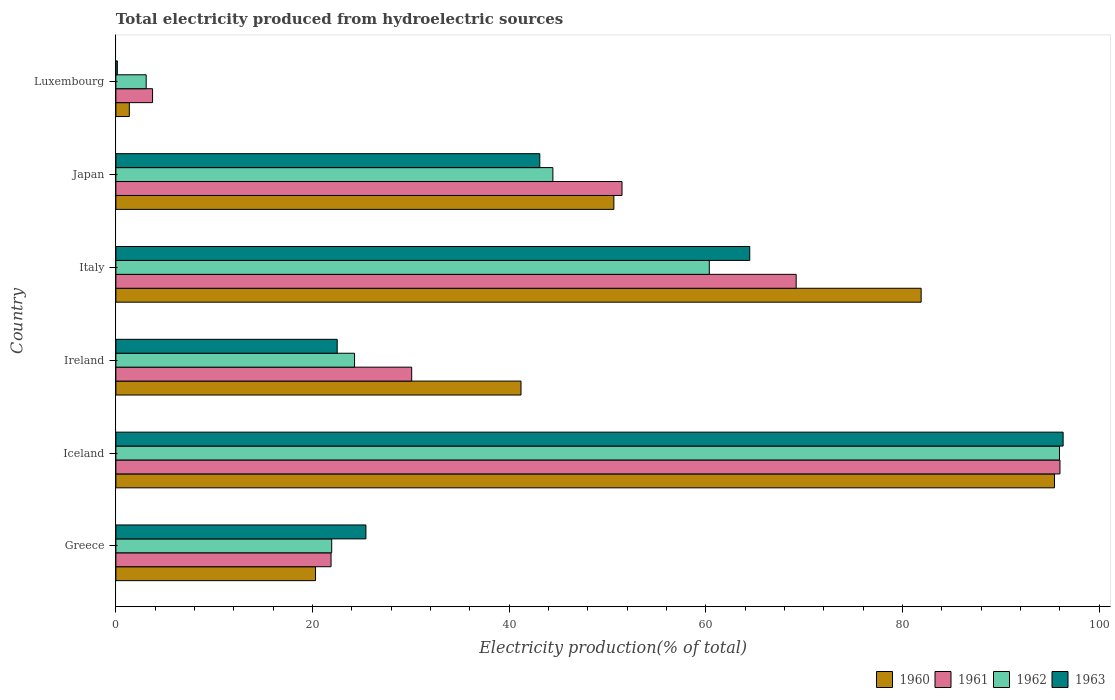Are the number of bars on each tick of the Y-axis equal?
Your response must be concise. Yes. How many bars are there on the 3rd tick from the top?
Your answer should be compact. 4. How many bars are there on the 1st tick from the bottom?
Offer a terse response. 4. What is the label of the 3rd group of bars from the top?
Make the answer very short. Italy. In how many cases, is the number of bars for a given country not equal to the number of legend labels?
Your answer should be compact. 0. What is the total electricity produced in 1962 in Luxembourg?
Your answer should be very brief. 3.08. Across all countries, what is the maximum total electricity produced in 1960?
Keep it short and to the point. 95.46. Across all countries, what is the minimum total electricity produced in 1962?
Offer a very short reply. 3.08. In which country was the total electricity produced in 1961 maximum?
Your answer should be very brief. Iceland. In which country was the total electricity produced in 1963 minimum?
Your response must be concise. Luxembourg. What is the total total electricity produced in 1960 in the graph?
Ensure brevity in your answer.  290.89. What is the difference between the total electricity produced in 1960 in Ireland and that in Italy?
Your answer should be very brief. -40.7. What is the difference between the total electricity produced in 1963 in Greece and the total electricity produced in 1961 in Iceland?
Your answer should be compact. -70.59. What is the average total electricity produced in 1962 per country?
Offer a terse response. 41.68. What is the difference between the total electricity produced in 1963 and total electricity produced in 1960 in Luxembourg?
Give a very brief answer. -1.22. What is the ratio of the total electricity produced in 1960 in Greece to that in Iceland?
Offer a very short reply. 0.21. What is the difference between the highest and the second highest total electricity produced in 1961?
Offer a very short reply. 26.83. What is the difference between the highest and the lowest total electricity produced in 1960?
Make the answer very short. 94.1. In how many countries, is the total electricity produced in 1962 greater than the average total electricity produced in 1962 taken over all countries?
Give a very brief answer. 3. What does the 3rd bar from the bottom in Japan represents?
Your answer should be very brief. 1962. How many bars are there?
Provide a short and direct response. 24. What is the difference between two consecutive major ticks on the X-axis?
Give a very brief answer. 20. Are the values on the major ticks of X-axis written in scientific E-notation?
Your answer should be very brief. No. Where does the legend appear in the graph?
Your answer should be very brief. Bottom right. How many legend labels are there?
Your response must be concise. 4. How are the legend labels stacked?
Provide a succinct answer. Horizontal. What is the title of the graph?
Ensure brevity in your answer.  Total electricity produced from hydroelectric sources. Does "1973" appear as one of the legend labels in the graph?
Your answer should be very brief. No. What is the label or title of the Y-axis?
Your response must be concise. Country. What is the Electricity production(% of total) in 1960 in Greece?
Your response must be concise. 20.31. What is the Electricity production(% of total) in 1961 in Greece?
Provide a short and direct response. 21.88. What is the Electricity production(% of total) in 1962 in Greece?
Ensure brevity in your answer.  21.95. What is the Electricity production(% of total) of 1963 in Greece?
Offer a very short reply. 25.43. What is the Electricity production(% of total) in 1960 in Iceland?
Offer a terse response. 95.46. What is the Electricity production(% of total) of 1961 in Iceland?
Offer a terse response. 96.02. What is the Electricity production(% of total) of 1962 in Iceland?
Make the answer very short. 95.97. What is the Electricity production(% of total) in 1963 in Iceland?
Give a very brief answer. 96.34. What is the Electricity production(% of total) in 1960 in Ireland?
Your answer should be compact. 41.2. What is the Electricity production(% of total) in 1961 in Ireland?
Your answer should be very brief. 30.09. What is the Electricity production(% of total) in 1962 in Ireland?
Keep it short and to the point. 24.27. What is the Electricity production(% of total) in 1963 in Ireland?
Give a very brief answer. 22.51. What is the Electricity production(% of total) of 1960 in Italy?
Offer a terse response. 81.9. What is the Electricity production(% of total) in 1961 in Italy?
Your answer should be compact. 69.19. What is the Electricity production(% of total) of 1962 in Italy?
Keep it short and to the point. 60.35. What is the Electricity production(% of total) in 1963 in Italy?
Your response must be concise. 64.47. What is the Electricity production(% of total) in 1960 in Japan?
Give a very brief answer. 50.65. What is the Electricity production(% of total) in 1961 in Japan?
Make the answer very short. 51.48. What is the Electricity production(% of total) in 1962 in Japan?
Your answer should be compact. 44.44. What is the Electricity production(% of total) of 1963 in Japan?
Your answer should be compact. 43.11. What is the Electricity production(% of total) in 1960 in Luxembourg?
Give a very brief answer. 1.37. What is the Electricity production(% of total) in 1961 in Luxembourg?
Give a very brief answer. 3.73. What is the Electricity production(% of total) of 1962 in Luxembourg?
Your answer should be compact. 3.08. What is the Electricity production(% of total) of 1963 in Luxembourg?
Ensure brevity in your answer.  0.15. Across all countries, what is the maximum Electricity production(% of total) of 1960?
Offer a very short reply. 95.46. Across all countries, what is the maximum Electricity production(% of total) in 1961?
Your response must be concise. 96.02. Across all countries, what is the maximum Electricity production(% of total) of 1962?
Offer a very short reply. 95.97. Across all countries, what is the maximum Electricity production(% of total) of 1963?
Your answer should be very brief. 96.34. Across all countries, what is the minimum Electricity production(% of total) in 1960?
Offer a terse response. 1.37. Across all countries, what is the minimum Electricity production(% of total) in 1961?
Your answer should be compact. 3.73. Across all countries, what is the minimum Electricity production(% of total) in 1962?
Ensure brevity in your answer.  3.08. Across all countries, what is the minimum Electricity production(% of total) in 1963?
Ensure brevity in your answer.  0.15. What is the total Electricity production(% of total) in 1960 in the graph?
Provide a succinct answer. 290.89. What is the total Electricity production(% of total) in 1961 in the graph?
Make the answer very short. 272.39. What is the total Electricity production(% of total) of 1962 in the graph?
Your answer should be compact. 250.08. What is the total Electricity production(% of total) in 1963 in the graph?
Offer a terse response. 252.01. What is the difference between the Electricity production(% of total) of 1960 in Greece and that in Iceland?
Your answer should be very brief. -75.16. What is the difference between the Electricity production(% of total) in 1961 in Greece and that in Iceland?
Provide a short and direct response. -74.14. What is the difference between the Electricity production(% of total) of 1962 in Greece and that in Iceland?
Make the answer very short. -74.02. What is the difference between the Electricity production(% of total) of 1963 in Greece and that in Iceland?
Offer a terse response. -70.91. What is the difference between the Electricity production(% of total) of 1960 in Greece and that in Ireland?
Offer a terse response. -20.9. What is the difference between the Electricity production(% of total) of 1961 in Greece and that in Ireland?
Offer a very short reply. -8.2. What is the difference between the Electricity production(% of total) in 1962 in Greece and that in Ireland?
Provide a short and direct response. -2.32. What is the difference between the Electricity production(% of total) in 1963 in Greece and that in Ireland?
Offer a terse response. 2.92. What is the difference between the Electricity production(% of total) in 1960 in Greece and that in Italy?
Your answer should be very brief. -61.59. What is the difference between the Electricity production(% of total) in 1961 in Greece and that in Italy?
Offer a terse response. -47.31. What is the difference between the Electricity production(% of total) in 1962 in Greece and that in Italy?
Provide a succinct answer. -38.4. What is the difference between the Electricity production(% of total) in 1963 in Greece and that in Italy?
Offer a terse response. -39.04. What is the difference between the Electricity production(% of total) in 1960 in Greece and that in Japan?
Offer a very short reply. -30.34. What is the difference between the Electricity production(% of total) in 1961 in Greece and that in Japan?
Keep it short and to the point. -29.59. What is the difference between the Electricity production(% of total) of 1962 in Greece and that in Japan?
Provide a succinct answer. -22.49. What is the difference between the Electricity production(% of total) of 1963 in Greece and that in Japan?
Your answer should be compact. -17.69. What is the difference between the Electricity production(% of total) of 1960 in Greece and that in Luxembourg?
Provide a short and direct response. 18.94. What is the difference between the Electricity production(% of total) of 1961 in Greece and that in Luxembourg?
Offer a very short reply. 18.15. What is the difference between the Electricity production(% of total) in 1962 in Greece and that in Luxembourg?
Your answer should be compact. 18.87. What is the difference between the Electricity production(% of total) of 1963 in Greece and that in Luxembourg?
Provide a short and direct response. 25.28. What is the difference between the Electricity production(% of total) of 1960 in Iceland and that in Ireland?
Your response must be concise. 54.26. What is the difference between the Electricity production(% of total) in 1961 in Iceland and that in Ireland?
Keep it short and to the point. 65.93. What is the difference between the Electricity production(% of total) of 1962 in Iceland and that in Ireland?
Provide a succinct answer. 71.7. What is the difference between the Electricity production(% of total) in 1963 in Iceland and that in Ireland?
Offer a very short reply. 73.83. What is the difference between the Electricity production(% of total) of 1960 in Iceland and that in Italy?
Your response must be concise. 13.56. What is the difference between the Electricity production(% of total) of 1961 in Iceland and that in Italy?
Offer a terse response. 26.83. What is the difference between the Electricity production(% of total) of 1962 in Iceland and that in Italy?
Ensure brevity in your answer.  35.62. What is the difference between the Electricity production(% of total) of 1963 in Iceland and that in Italy?
Make the answer very short. 31.87. What is the difference between the Electricity production(% of total) in 1960 in Iceland and that in Japan?
Ensure brevity in your answer.  44.81. What is the difference between the Electricity production(% of total) of 1961 in Iceland and that in Japan?
Your answer should be compact. 44.54. What is the difference between the Electricity production(% of total) of 1962 in Iceland and that in Japan?
Keep it short and to the point. 51.53. What is the difference between the Electricity production(% of total) in 1963 in Iceland and that in Japan?
Give a very brief answer. 53.23. What is the difference between the Electricity production(% of total) of 1960 in Iceland and that in Luxembourg?
Ensure brevity in your answer.  94.1. What is the difference between the Electricity production(% of total) in 1961 in Iceland and that in Luxembourg?
Make the answer very short. 92.29. What is the difference between the Electricity production(% of total) in 1962 in Iceland and that in Luxembourg?
Offer a very short reply. 92.89. What is the difference between the Electricity production(% of total) in 1963 in Iceland and that in Luxembourg?
Your answer should be very brief. 96.19. What is the difference between the Electricity production(% of total) of 1960 in Ireland and that in Italy?
Offer a very short reply. -40.7. What is the difference between the Electricity production(% of total) in 1961 in Ireland and that in Italy?
Provide a succinct answer. -39.1. What is the difference between the Electricity production(% of total) in 1962 in Ireland and that in Italy?
Offer a very short reply. -36.08. What is the difference between the Electricity production(% of total) of 1963 in Ireland and that in Italy?
Your response must be concise. -41.96. What is the difference between the Electricity production(% of total) in 1960 in Ireland and that in Japan?
Keep it short and to the point. -9.45. What is the difference between the Electricity production(% of total) in 1961 in Ireland and that in Japan?
Your answer should be compact. -21.39. What is the difference between the Electricity production(% of total) of 1962 in Ireland and that in Japan?
Make the answer very short. -20.17. What is the difference between the Electricity production(% of total) in 1963 in Ireland and that in Japan?
Provide a succinct answer. -20.61. What is the difference between the Electricity production(% of total) of 1960 in Ireland and that in Luxembourg?
Make the answer very short. 39.84. What is the difference between the Electricity production(% of total) of 1961 in Ireland and that in Luxembourg?
Give a very brief answer. 26.36. What is the difference between the Electricity production(% of total) in 1962 in Ireland and that in Luxembourg?
Provide a succinct answer. 21.19. What is the difference between the Electricity production(% of total) of 1963 in Ireland and that in Luxembourg?
Your answer should be very brief. 22.36. What is the difference between the Electricity production(% of total) of 1960 in Italy and that in Japan?
Give a very brief answer. 31.25. What is the difference between the Electricity production(% of total) of 1961 in Italy and that in Japan?
Offer a very short reply. 17.71. What is the difference between the Electricity production(% of total) in 1962 in Italy and that in Japan?
Your answer should be very brief. 15.91. What is the difference between the Electricity production(% of total) in 1963 in Italy and that in Japan?
Make the answer very short. 21.35. What is the difference between the Electricity production(% of total) in 1960 in Italy and that in Luxembourg?
Your answer should be compact. 80.53. What is the difference between the Electricity production(% of total) of 1961 in Italy and that in Luxembourg?
Your answer should be very brief. 65.46. What is the difference between the Electricity production(% of total) of 1962 in Italy and that in Luxembourg?
Provide a short and direct response. 57.27. What is the difference between the Electricity production(% of total) of 1963 in Italy and that in Luxembourg?
Give a very brief answer. 64.32. What is the difference between the Electricity production(% of total) of 1960 in Japan and that in Luxembourg?
Make the answer very short. 49.28. What is the difference between the Electricity production(% of total) of 1961 in Japan and that in Luxembourg?
Give a very brief answer. 47.75. What is the difference between the Electricity production(% of total) in 1962 in Japan and that in Luxembourg?
Provide a short and direct response. 41.36. What is the difference between the Electricity production(% of total) in 1963 in Japan and that in Luxembourg?
Offer a very short reply. 42.97. What is the difference between the Electricity production(% of total) of 1960 in Greece and the Electricity production(% of total) of 1961 in Iceland?
Give a very brief answer. -75.71. What is the difference between the Electricity production(% of total) of 1960 in Greece and the Electricity production(% of total) of 1962 in Iceland?
Keep it short and to the point. -75.67. What is the difference between the Electricity production(% of total) of 1960 in Greece and the Electricity production(% of total) of 1963 in Iceland?
Offer a terse response. -76.04. What is the difference between the Electricity production(% of total) in 1961 in Greece and the Electricity production(% of total) in 1962 in Iceland?
Keep it short and to the point. -74.09. What is the difference between the Electricity production(% of total) in 1961 in Greece and the Electricity production(% of total) in 1963 in Iceland?
Provide a short and direct response. -74.46. What is the difference between the Electricity production(% of total) in 1962 in Greece and the Electricity production(% of total) in 1963 in Iceland?
Give a very brief answer. -74.39. What is the difference between the Electricity production(% of total) in 1960 in Greece and the Electricity production(% of total) in 1961 in Ireland?
Your answer should be very brief. -9.78. What is the difference between the Electricity production(% of total) in 1960 in Greece and the Electricity production(% of total) in 1962 in Ireland?
Provide a short and direct response. -3.97. What is the difference between the Electricity production(% of total) of 1960 in Greece and the Electricity production(% of total) of 1963 in Ireland?
Your answer should be compact. -2.2. What is the difference between the Electricity production(% of total) of 1961 in Greece and the Electricity production(% of total) of 1962 in Ireland?
Your answer should be very brief. -2.39. What is the difference between the Electricity production(% of total) in 1961 in Greece and the Electricity production(% of total) in 1963 in Ireland?
Your answer should be very brief. -0.63. What is the difference between the Electricity production(% of total) in 1962 in Greece and the Electricity production(% of total) in 1963 in Ireland?
Ensure brevity in your answer.  -0.56. What is the difference between the Electricity production(% of total) of 1960 in Greece and the Electricity production(% of total) of 1961 in Italy?
Offer a very short reply. -48.88. What is the difference between the Electricity production(% of total) of 1960 in Greece and the Electricity production(% of total) of 1962 in Italy?
Provide a succinct answer. -40.05. What is the difference between the Electricity production(% of total) in 1960 in Greece and the Electricity production(% of total) in 1963 in Italy?
Ensure brevity in your answer.  -44.16. What is the difference between the Electricity production(% of total) in 1961 in Greece and the Electricity production(% of total) in 1962 in Italy?
Provide a short and direct response. -38.47. What is the difference between the Electricity production(% of total) of 1961 in Greece and the Electricity production(% of total) of 1963 in Italy?
Your answer should be compact. -42.58. What is the difference between the Electricity production(% of total) in 1962 in Greece and the Electricity production(% of total) in 1963 in Italy?
Your answer should be very brief. -42.52. What is the difference between the Electricity production(% of total) of 1960 in Greece and the Electricity production(% of total) of 1961 in Japan?
Give a very brief answer. -31.17. What is the difference between the Electricity production(% of total) of 1960 in Greece and the Electricity production(% of total) of 1962 in Japan?
Your answer should be very brief. -24.14. What is the difference between the Electricity production(% of total) of 1960 in Greece and the Electricity production(% of total) of 1963 in Japan?
Ensure brevity in your answer.  -22.81. What is the difference between the Electricity production(% of total) of 1961 in Greece and the Electricity production(% of total) of 1962 in Japan?
Offer a terse response. -22.56. What is the difference between the Electricity production(% of total) of 1961 in Greece and the Electricity production(% of total) of 1963 in Japan?
Provide a succinct answer. -21.23. What is the difference between the Electricity production(% of total) in 1962 in Greece and the Electricity production(% of total) in 1963 in Japan?
Provide a short and direct response. -21.16. What is the difference between the Electricity production(% of total) of 1960 in Greece and the Electricity production(% of total) of 1961 in Luxembourg?
Provide a short and direct response. 16.58. What is the difference between the Electricity production(% of total) in 1960 in Greece and the Electricity production(% of total) in 1962 in Luxembourg?
Offer a terse response. 17.22. What is the difference between the Electricity production(% of total) in 1960 in Greece and the Electricity production(% of total) in 1963 in Luxembourg?
Offer a very short reply. 20.16. What is the difference between the Electricity production(% of total) in 1961 in Greece and the Electricity production(% of total) in 1962 in Luxembourg?
Offer a very short reply. 18.8. What is the difference between the Electricity production(% of total) of 1961 in Greece and the Electricity production(% of total) of 1963 in Luxembourg?
Provide a succinct answer. 21.74. What is the difference between the Electricity production(% of total) in 1962 in Greece and the Electricity production(% of total) in 1963 in Luxembourg?
Your response must be concise. 21.8. What is the difference between the Electricity production(% of total) in 1960 in Iceland and the Electricity production(% of total) in 1961 in Ireland?
Make the answer very short. 65.38. What is the difference between the Electricity production(% of total) in 1960 in Iceland and the Electricity production(% of total) in 1962 in Ireland?
Your answer should be very brief. 71.19. What is the difference between the Electricity production(% of total) in 1960 in Iceland and the Electricity production(% of total) in 1963 in Ireland?
Make the answer very short. 72.95. What is the difference between the Electricity production(% of total) of 1961 in Iceland and the Electricity production(% of total) of 1962 in Ireland?
Ensure brevity in your answer.  71.75. What is the difference between the Electricity production(% of total) of 1961 in Iceland and the Electricity production(% of total) of 1963 in Ireland?
Your answer should be very brief. 73.51. What is the difference between the Electricity production(% of total) in 1962 in Iceland and the Electricity production(% of total) in 1963 in Ireland?
Offer a terse response. 73.47. What is the difference between the Electricity production(% of total) in 1960 in Iceland and the Electricity production(% of total) in 1961 in Italy?
Provide a succinct answer. 26.27. What is the difference between the Electricity production(% of total) of 1960 in Iceland and the Electricity production(% of total) of 1962 in Italy?
Provide a short and direct response. 35.11. What is the difference between the Electricity production(% of total) of 1960 in Iceland and the Electricity production(% of total) of 1963 in Italy?
Your response must be concise. 30.99. What is the difference between the Electricity production(% of total) of 1961 in Iceland and the Electricity production(% of total) of 1962 in Italy?
Ensure brevity in your answer.  35.67. What is the difference between the Electricity production(% of total) of 1961 in Iceland and the Electricity production(% of total) of 1963 in Italy?
Provide a short and direct response. 31.55. What is the difference between the Electricity production(% of total) of 1962 in Iceland and the Electricity production(% of total) of 1963 in Italy?
Ensure brevity in your answer.  31.51. What is the difference between the Electricity production(% of total) in 1960 in Iceland and the Electricity production(% of total) in 1961 in Japan?
Make the answer very short. 43.99. What is the difference between the Electricity production(% of total) of 1960 in Iceland and the Electricity production(% of total) of 1962 in Japan?
Give a very brief answer. 51.02. What is the difference between the Electricity production(% of total) of 1960 in Iceland and the Electricity production(% of total) of 1963 in Japan?
Provide a short and direct response. 52.35. What is the difference between the Electricity production(% of total) of 1961 in Iceland and the Electricity production(% of total) of 1962 in Japan?
Your response must be concise. 51.58. What is the difference between the Electricity production(% of total) of 1961 in Iceland and the Electricity production(% of total) of 1963 in Japan?
Provide a succinct answer. 52.91. What is the difference between the Electricity production(% of total) of 1962 in Iceland and the Electricity production(% of total) of 1963 in Japan?
Your answer should be very brief. 52.86. What is the difference between the Electricity production(% of total) in 1960 in Iceland and the Electricity production(% of total) in 1961 in Luxembourg?
Provide a short and direct response. 91.73. What is the difference between the Electricity production(% of total) in 1960 in Iceland and the Electricity production(% of total) in 1962 in Luxembourg?
Your response must be concise. 92.38. What is the difference between the Electricity production(% of total) in 1960 in Iceland and the Electricity production(% of total) in 1963 in Luxembourg?
Ensure brevity in your answer.  95.32. What is the difference between the Electricity production(% of total) in 1961 in Iceland and the Electricity production(% of total) in 1962 in Luxembourg?
Your response must be concise. 92.94. What is the difference between the Electricity production(% of total) of 1961 in Iceland and the Electricity production(% of total) of 1963 in Luxembourg?
Your answer should be compact. 95.87. What is the difference between the Electricity production(% of total) in 1962 in Iceland and the Electricity production(% of total) in 1963 in Luxembourg?
Provide a short and direct response. 95.83. What is the difference between the Electricity production(% of total) of 1960 in Ireland and the Electricity production(% of total) of 1961 in Italy?
Offer a very short reply. -27.99. What is the difference between the Electricity production(% of total) in 1960 in Ireland and the Electricity production(% of total) in 1962 in Italy?
Your response must be concise. -19.15. What is the difference between the Electricity production(% of total) in 1960 in Ireland and the Electricity production(% of total) in 1963 in Italy?
Make the answer very short. -23.27. What is the difference between the Electricity production(% of total) in 1961 in Ireland and the Electricity production(% of total) in 1962 in Italy?
Provide a short and direct response. -30.27. What is the difference between the Electricity production(% of total) of 1961 in Ireland and the Electricity production(% of total) of 1963 in Italy?
Keep it short and to the point. -34.38. What is the difference between the Electricity production(% of total) in 1962 in Ireland and the Electricity production(% of total) in 1963 in Italy?
Provide a succinct answer. -40.2. What is the difference between the Electricity production(% of total) in 1960 in Ireland and the Electricity production(% of total) in 1961 in Japan?
Your answer should be very brief. -10.27. What is the difference between the Electricity production(% of total) in 1960 in Ireland and the Electricity production(% of total) in 1962 in Japan?
Your answer should be compact. -3.24. What is the difference between the Electricity production(% of total) of 1960 in Ireland and the Electricity production(% of total) of 1963 in Japan?
Make the answer very short. -1.91. What is the difference between the Electricity production(% of total) in 1961 in Ireland and the Electricity production(% of total) in 1962 in Japan?
Your answer should be very brief. -14.36. What is the difference between the Electricity production(% of total) in 1961 in Ireland and the Electricity production(% of total) in 1963 in Japan?
Offer a terse response. -13.03. What is the difference between the Electricity production(% of total) in 1962 in Ireland and the Electricity production(% of total) in 1963 in Japan?
Offer a terse response. -18.84. What is the difference between the Electricity production(% of total) in 1960 in Ireland and the Electricity production(% of total) in 1961 in Luxembourg?
Give a very brief answer. 37.47. What is the difference between the Electricity production(% of total) of 1960 in Ireland and the Electricity production(% of total) of 1962 in Luxembourg?
Provide a short and direct response. 38.12. What is the difference between the Electricity production(% of total) of 1960 in Ireland and the Electricity production(% of total) of 1963 in Luxembourg?
Keep it short and to the point. 41.05. What is the difference between the Electricity production(% of total) of 1961 in Ireland and the Electricity production(% of total) of 1962 in Luxembourg?
Provide a succinct answer. 27. What is the difference between the Electricity production(% of total) of 1961 in Ireland and the Electricity production(% of total) of 1963 in Luxembourg?
Keep it short and to the point. 29.94. What is the difference between the Electricity production(% of total) of 1962 in Ireland and the Electricity production(% of total) of 1963 in Luxembourg?
Your answer should be very brief. 24.12. What is the difference between the Electricity production(% of total) in 1960 in Italy and the Electricity production(% of total) in 1961 in Japan?
Offer a very short reply. 30.42. What is the difference between the Electricity production(% of total) in 1960 in Italy and the Electricity production(% of total) in 1962 in Japan?
Provide a short and direct response. 37.46. What is the difference between the Electricity production(% of total) of 1960 in Italy and the Electricity production(% of total) of 1963 in Japan?
Provide a succinct answer. 38.79. What is the difference between the Electricity production(% of total) in 1961 in Italy and the Electricity production(% of total) in 1962 in Japan?
Provide a short and direct response. 24.75. What is the difference between the Electricity production(% of total) in 1961 in Italy and the Electricity production(% of total) in 1963 in Japan?
Ensure brevity in your answer.  26.08. What is the difference between the Electricity production(% of total) of 1962 in Italy and the Electricity production(% of total) of 1963 in Japan?
Provide a short and direct response. 17.24. What is the difference between the Electricity production(% of total) of 1960 in Italy and the Electricity production(% of total) of 1961 in Luxembourg?
Offer a terse response. 78.17. What is the difference between the Electricity production(% of total) in 1960 in Italy and the Electricity production(% of total) in 1962 in Luxembourg?
Your answer should be very brief. 78.82. What is the difference between the Electricity production(% of total) of 1960 in Italy and the Electricity production(% of total) of 1963 in Luxembourg?
Your answer should be very brief. 81.75. What is the difference between the Electricity production(% of total) of 1961 in Italy and the Electricity production(% of total) of 1962 in Luxembourg?
Your answer should be very brief. 66.11. What is the difference between the Electricity production(% of total) of 1961 in Italy and the Electricity production(% of total) of 1963 in Luxembourg?
Your answer should be very brief. 69.04. What is the difference between the Electricity production(% of total) of 1962 in Italy and the Electricity production(% of total) of 1963 in Luxembourg?
Ensure brevity in your answer.  60.21. What is the difference between the Electricity production(% of total) of 1960 in Japan and the Electricity production(% of total) of 1961 in Luxembourg?
Keep it short and to the point. 46.92. What is the difference between the Electricity production(% of total) in 1960 in Japan and the Electricity production(% of total) in 1962 in Luxembourg?
Offer a very short reply. 47.57. What is the difference between the Electricity production(% of total) in 1960 in Japan and the Electricity production(% of total) in 1963 in Luxembourg?
Offer a very short reply. 50.5. What is the difference between the Electricity production(% of total) in 1961 in Japan and the Electricity production(% of total) in 1962 in Luxembourg?
Offer a terse response. 48.39. What is the difference between the Electricity production(% of total) in 1961 in Japan and the Electricity production(% of total) in 1963 in Luxembourg?
Your answer should be compact. 51.33. What is the difference between the Electricity production(% of total) of 1962 in Japan and the Electricity production(% of total) of 1963 in Luxembourg?
Give a very brief answer. 44.3. What is the average Electricity production(% of total) of 1960 per country?
Your answer should be very brief. 48.48. What is the average Electricity production(% of total) in 1961 per country?
Your answer should be very brief. 45.4. What is the average Electricity production(% of total) of 1962 per country?
Keep it short and to the point. 41.68. What is the average Electricity production(% of total) in 1963 per country?
Offer a terse response. 42. What is the difference between the Electricity production(% of total) of 1960 and Electricity production(% of total) of 1961 in Greece?
Your answer should be very brief. -1.58. What is the difference between the Electricity production(% of total) of 1960 and Electricity production(% of total) of 1962 in Greece?
Provide a succinct answer. -1.64. What is the difference between the Electricity production(% of total) in 1960 and Electricity production(% of total) in 1963 in Greece?
Give a very brief answer. -5.12. What is the difference between the Electricity production(% of total) of 1961 and Electricity production(% of total) of 1962 in Greece?
Your response must be concise. -0.07. What is the difference between the Electricity production(% of total) of 1961 and Electricity production(% of total) of 1963 in Greece?
Provide a succinct answer. -3.54. What is the difference between the Electricity production(% of total) in 1962 and Electricity production(% of total) in 1963 in Greece?
Keep it short and to the point. -3.48. What is the difference between the Electricity production(% of total) of 1960 and Electricity production(% of total) of 1961 in Iceland?
Provide a succinct answer. -0.56. What is the difference between the Electricity production(% of total) of 1960 and Electricity production(% of total) of 1962 in Iceland?
Your response must be concise. -0.51. What is the difference between the Electricity production(% of total) of 1960 and Electricity production(% of total) of 1963 in Iceland?
Your answer should be compact. -0.88. What is the difference between the Electricity production(% of total) of 1961 and Electricity production(% of total) of 1962 in Iceland?
Offer a very short reply. 0.05. What is the difference between the Electricity production(% of total) of 1961 and Electricity production(% of total) of 1963 in Iceland?
Keep it short and to the point. -0.32. What is the difference between the Electricity production(% of total) of 1962 and Electricity production(% of total) of 1963 in Iceland?
Your answer should be very brief. -0.37. What is the difference between the Electricity production(% of total) in 1960 and Electricity production(% of total) in 1961 in Ireland?
Make the answer very short. 11.12. What is the difference between the Electricity production(% of total) in 1960 and Electricity production(% of total) in 1962 in Ireland?
Keep it short and to the point. 16.93. What is the difference between the Electricity production(% of total) of 1960 and Electricity production(% of total) of 1963 in Ireland?
Your answer should be very brief. 18.69. What is the difference between the Electricity production(% of total) of 1961 and Electricity production(% of total) of 1962 in Ireland?
Make the answer very short. 5.81. What is the difference between the Electricity production(% of total) in 1961 and Electricity production(% of total) in 1963 in Ireland?
Your answer should be very brief. 7.58. What is the difference between the Electricity production(% of total) in 1962 and Electricity production(% of total) in 1963 in Ireland?
Offer a terse response. 1.76. What is the difference between the Electricity production(% of total) in 1960 and Electricity production(% of total) in 1961 in Italy?
Give a very brief answer. 12.71. What is the difference between the Electricity production(% of total) of 1960 and Electricity production(% of total) of 1962 in Italy?
Give a very brief answer. 21.55. What is the difference between the Electricity production(% of total) in 1960 and Electricity production(% of total) in 1963 in Italy?
Offer a terse response. 17.43. What is the difference between the Electricity production(% of total) of 1961 and Electricity production(% of total) of 1962 in Italy?
Provide a short and direct response. 8.84. What is the difference between the Electricity production(% of total) of 1961 and Electricity production(% of total) of 1963 in Italy?
Your answer should be compact. 4.72. What is the difference between the Electricity production(% of total) in 1962 and Electricity production(% of total) in 1963 in Italy?
Offer a very short reply. -4.11. What is the difference between the Electricity production(% of total) of 1960 and Electricity production(% of total) of 1961 in Japan?
Ensure brevity in your answer.  -0.83. What is the difference between the Electricity production(% of total) in 1960 and Electricity production(% of total) in 1962 in Japan?
Provide a succinct answer. 6.2. What is the difference between the Electricity production(% of total) in 1960 and Electricity production(% of total) in 1963 in Japan?
Provide a succinct answer. 7.54. What is the difference between the Electricity production(% of total) of 1961 and Electricity production(% of total) of 1962 in Japan?
Provide a short and direct response. 7.03. What is the difference between the Electricity production(% of total) in 1961 and Electricity production(% of total) in 1963 in Japan?
Provide a succinct answer. 8.36. What is the difference between the Electricity production(% of total) in 1962 and Electricity production(% of total) in 1963 in Japan?
Your response must be concise. 1.33. What is the difference between the Electricity production(% of total) in 1960 and Electricity production(% of total) in 1961 in Luxembourg?
Make the answer very short. -2.36. What is the difference between the Electricity production(% of total) of 1960 and Electricity production(% of total) of 1962 in Luxembourg?
Ensure brevity in your answer.  -1.72. What is the difference between the Electricity production(% of total) of 1960 and Electricity production(% of total) of 1963 in Luxembourg?
Keep it short and to the point. 1.22. What is the difference between the Electricity production(% of total) of 1961 and Electricity production(% of total) of 1962 in Luxembourg?
Provide a succinct answer. 0.65. What is the difference between the Electricity production(% of total) in 1961 and Electricity production(% of total) in 1963 in Luxembourg?
Keep it short and to the point. 3.58. What is the difference between the Electricity production(% of total) in 1962 and Electricity production(% of total) in 1963 in Luxembourg?
Make the answer very short. 2.93. What is the ratio of the Electricity production(% of total) of 1960 in Greece to that in Iceland?
Ensure brevity in your answer.  0.21. What is the ratio of the Electricity production(% of total) of 1961 in Greece to that in Iceland?
Your answer should be very brief. 0.23. What is the ratio of the Electricity production(% of total) of 1962 in Greece to that in Iceland?
Offer a terse response. 0.23. What is the ratio of the Electricity production(% of total) of 1963 in Greece to that in Iceland?
Provide a short and direct response. 0.26. What is the ratio of the Electricity production(% of total) in 1960 in Greece to that in Ireland?
Provide a succinct answer. 0.49. What is the ratio of the Electricity production(% of total) of 1961 in Greece to that in Ireland?
Make the answer very short. 0.73. What is the ratio of the Electricity production(% of total) in 1962 in Greece to that in Ireland?
Provide a succinct answer. 0.9. What is the ratio of the Electricity production(% of total) in 1963 in Greece to that in Ireland?
Offer a very short reply. 1.13. What is the ratio of the Electricity production(% of total) in 1960 in Greece to that in Italy?
Provide a succinct answer. 0.25. What is the ratio of the Electricity production(% of total) of 1961 in Greece to that in Italy?
Your answer should be very brief. 0.32. What is the ratio of the Electricity production(% of total) of 1962 in Greece to that in Italy?
Offer a very short reply. 0.36. What is the ratio of the Electricity production(% of total) in 1963 in Greece to that in Italy?
Provide a succinct answer. 0.39. What is the ratio of the Electricity production(% of total) of 1960 in Greece to that in Japan?
Make the answer very short. 0.4. What is the ratio of the Electricity production(% of total) of 1961 in Greece to that in Japan?
Ensure brevity in your answer.  0.43. What is the ratio of the Electricity production(% of total) in 1962 in Greece to that in Japan?
Your answer should be very brief. 0.49. What is the ratio of the Electricity production(% of total) in 1963 in Greece to that in Japan?
Provide a short and direct response. 0.59. What is the ratio of the Electricity production(% of total) of 1960 in Greece to that in Luxembourg?
Offer a very short reply. 14.86. What is the ratio of the Electricity production(% of total) of 1961 in Greece to that in Luxembourg?
Give a very brief answer. 5.87. What is the ratio of the Electricity production(% of total) of 1962 in Greece to that in Luxembourg?
Provide a succinct answer. 7.12. What is the ratio of the Electricity production(% of total) in 1963 in Greece to that in Luxembourg?
Ensure brevity in your answer.  172.27. What is the ratio of the Electricity production(% of total) of 1960 in Iceland to that in Ireland?
Keep it short and to the point. 2.32. What is the ratio of the Electricity production(% of total) of 1961 in Iceland to that in Ireland?
Provide a short and direct response. 3.19. What is the ratio of the Electricity production(% of total) of 1962 in Iceland to that in Ireland?
Your response must be concise. 3.95. What is the ratio of the Electricity production(% of total) in 1963 in Iceland to that in Ireland?
Give a very brief answer. 4.28. What is the ratio of the Electricity production(% of total) of 1960 in Iceland to that in Italy?
Offer a very short reply. 1.17. What is the ratio of the Electricity production(% of total) of 1961 in Iceland to that in Italy?
Offer a very short reply. 1.39. What is the ratio of the Electricity production(% of total) of 1962 in Iceland to that in Italy?
Provide a succinct answer. 1.59. What is the ratio of the Electricity production(% of total) of 1963 in Iceland to that in Italy?
Provide a short and direct response. 1.49. What is the ratio of the Electricity production(% of total) in 1960 in Iceland to that in Japan?
Provide a succinct answer. 1.88. What is the ratio of the Electricity production(% of total) of 1961 in Iceland to that in Japan?
Your response must be concise. 1.87. What is the ratio of the Electricity production(% of total) of 1962 in Iceland to that in Japan?
Ensure brevity in your answer.  2.16. What is the ratio of the Electricity production(% of total) in 1963 in Iceland to that in Japan?
Ensure brevity in your answer.  2.23. What is the ratio of the Electricity production(% of total) in 1960 in Iceland to that in Luxembourg?
Provide a succinct answer. 69.88. What is the ratio of the Electricity production(% of total) of 1961 in Iceland to that in Luxembourg?
Your answer should be very brief. 25.74. What is the ratio of the Electricity production(% of total) in 1962 in Iceland to that in Luxembourg?
Ensure brevity in your answer.  31.14. What is the ratio of the Electricity production(% of total) in 1963 in Iceland to that in Luxembourg?
Provide a succinct answer. 652.71. What is the ratio of the Electricity production(% of total) of 1960 in Ireland to that in Italy?
Your response must be concise. 0.5. What is the ratio of the Electricity production(% of total) in 1961 in Ireland to that in Italy?
Your answer should be very brief. 0.43. What is the ratio of the Electricity production(% of total) of 1962 in Ireland to that in Italy?
Provide a succinct answer. 0.4. What is the ratio of the Electricity production(% of total) in 1963 in Ireland to that in Italy?
Provide a succinct answer. 0.35. What is the ratio of the Electricity production(% of total) of 1960 in Ireland to that in Japan?
Ensure brevity in your answer.  0.81. What is the ratio of the Electricity production(% of total) of 1961 in Ireland to that in Japan?
Make the answer very short. 0.58. What is the ratio of the Electricity production(% of total) in 1962 in Ireland to that in Japan?
Provide a short and direct response. 0.55. What is the ratio of the Electricity production(% of total) of 1963 in Ireland to that in Japan?
Provide a short and direct response. 0.52. What is the ratio of the Electricity production(% of total) of 1960 in Ireland to that in Luxembourg?
Your answer should be very brief. 30.16. What is the ratio of the Electricity production(% of total) in 1961 in Ireland to that in Luxembourg?
Give a very brief answer. 8.07. What is the ratio of the Electricity production(% of total) in 1962 in Ireland to that in Luxembourg?
Offer a terse response. 7.88. What is the ratio of the Electricity production(% of total) in 1963 in Ireland to that in Luxembourg?
Provide a short and direct response. 152.5. What is the ratio of the Electricity production(% of total) of 1960 in Italy to that in Japan?
Your answer should be very brief. 1.62. What is the ratio of the Electricity production(% of total) of 1961 in Italy to that in Japan?
Ensure brevity in your answer.  1.34. What is the ratio of the Electricity production(% of total) in 1962 in Italy to that in Japan?
Offer a very short reply. 1.36. What is the ratio of the Electricity production(% of total) of 1963 in Italy to that in Japan?
Offer a very short reply. 1.5. What is the ratio of the Electricity production(% of total) in 1960 in Italy to that in Luxembourg?
Ensure brevity in your answer.  59.95. What is the ratio of the Electricity production(% of total) in 1961 in Italy to that in Luxembourg?
Your answer should be compact. 18.55. What is the ratio of the Electricity production(% of total) of 1962 in Italy to that in Luxembourg?
Offer a very short reply. 19.58. What is the ratio of the Electricity production(% of total) of 1963 in Italy to that in Luxembourg?
Offer a very short reply. 436.77. What is the ratio of the Electricity production(% of total) of 1960 in Japan to that in Luxembourg?
Provide a short and direct response. 37.08. What is the ratio of the Electricity production(% of total) in 1961 in Japan to that in Luxembourg?
Your answer should be very brief. 13.8. What is the ratio of the Electricity production(% of total) of 1962 in Japan to that in Luxembourg?
Make the answer very short. 14.42. What is the ratio of the Electricity production(% of total) of 1963 in Japan to that in Luxembourg?
Ensure brevity in your answer.  292.1. What is the difference between the highest and the second highest Electricity production(% of total) in 1960?
Make the answer very short. 13.56. What is the difference between the highest and the second highest Electricity production(% of total) of 1961?
Offer a terse response. 26.83. What is the difference between the highest and the second highest Electricity production(% of total) in 1962?
Give a very brief answer. 35.62. What is the difference between the highest and the second highest Electricity production(% of total) in 1963?
Make the answer very short. 31.87. What is the difference between the highest and the lowest Electricity production(% of total) in 1960?
Provide a succinct answer. 94.1. What is the difference between the highest and the lowest Electricity production(% of total) of 1961?
Ensure brevity in your answer.  92.29. What is the difference between the highest and the lowest Electricity production(% of total) of 1962?
Offer a terse response. 92.89. What is the difference between the highest and the lowest Electricity production(% of total) in 1963?
Keep it short and to the point. 96.19. 